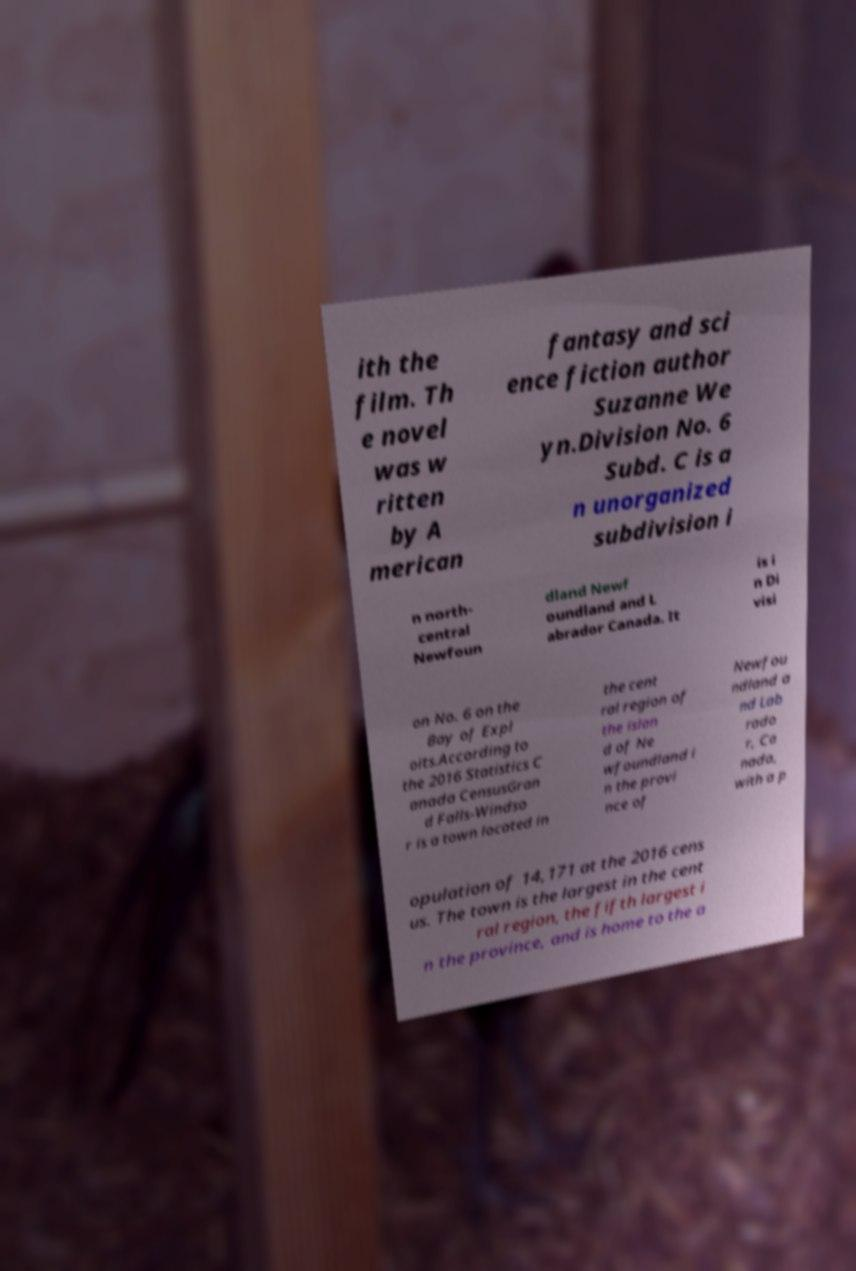Could you assist in decoding the text presented in this image and type it out clearly? ith the film. Th e novel was w ritten by A merican fantasy and sci ence fiction author Suzanne We yn.Division No. 6 Subd. C is a n unorganized subdivision i n north- central Newfoun dland Newf oundland and L abrador Canada. It is i n Di visi on No. 6 on the Bay of Expl oits.According to the 2016 Statistics C anada CensusGran d Falls-Windso r is a town located in the cent ral region of the islan d of Ne wfoundland i n the provi nce of Newfou ndland a nd Lab rado r, Ca nada, with a p opulation of 14,171 at the 2016 cens us. The town is the largest in the cent ral region, the fifth largest i n the province, and is home to the a 